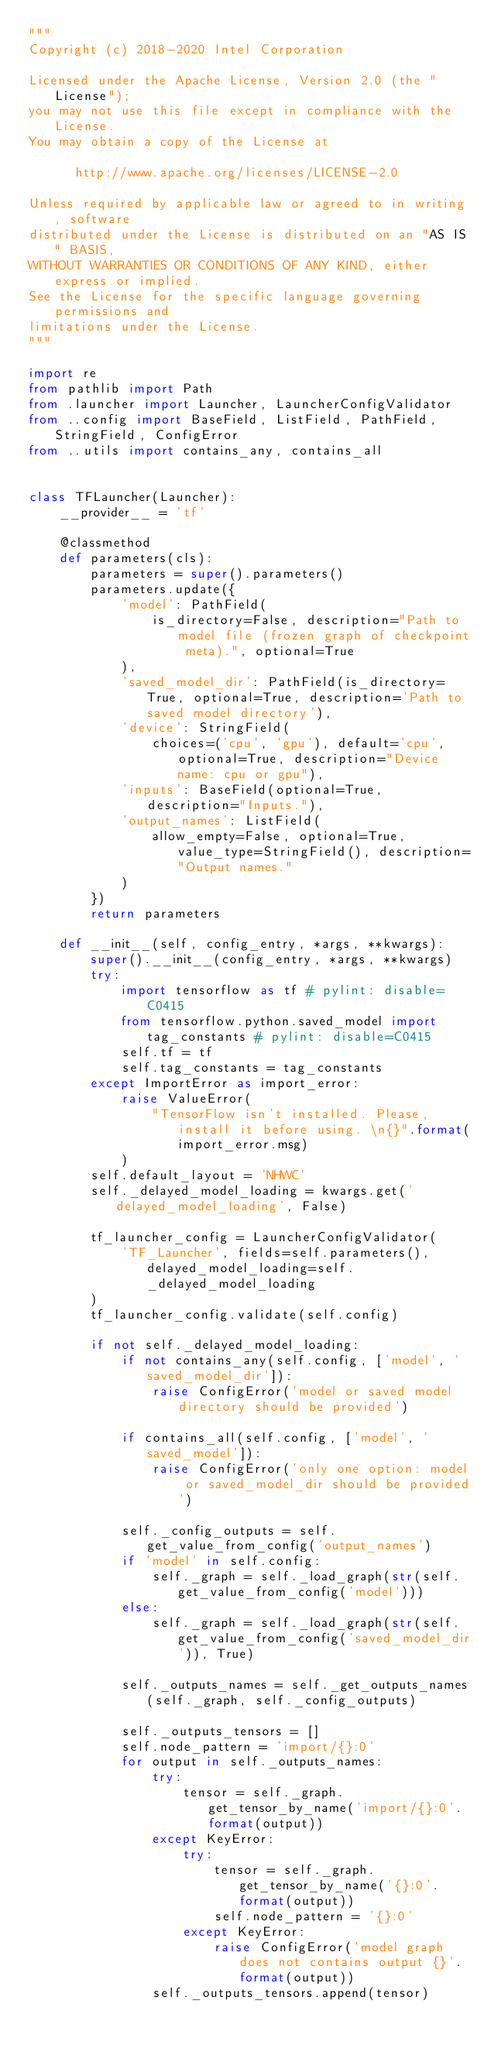<code> <loc_0><loc_0><loc_500><loc_500><_Python_>"""
Copyright (c) 2018-2020 Intel Corporation

Licensed under the Apache License, Version 2.0 (the "License");
you may not use this file except in compliance with the License.
You may obtain a copy of the License at

      http://www.apache.org/licenses/LICENSE-2.0

Unless required by applicable law or agreed to in writing, software
distributed under the License is distributed on an "AS IS" BASIS,
WITHOUT WARRANTIES OR CONDITIONS OF ANY KIND, either express or implied.
See the License for the specific language governing permissions and
limitations under the License.
"""

import re
from pathlib import Path
from .launcher import Launcher, LauncherConfigValidator
from ..config import BaseField, ListField, PathField, StringField, ConfigError
from ..utils import contains_any, contains_all


class TFLauncher(Launcher):
    __provider__ = 'tf'

    @classmethod
    def parameters(cls):
        parameters = super().parameters()
        parameters.update({
            'model': PathField(
                is_directory=False, description="Path to model file (frozen graph of checkpoint meta).", optional=True
            ),
            'saved_model_dir': PathField(is_directory=True, optional=True, description='Path to saved model directory'),
            'device': StringField(
                choices=('cpu', 'gpu'), default='cpu', optional=True, description="Device name: cpu or gpu"),
            'inputs': BaseField(optional=True, description="Inputs."),
            'output_names': ListField(
                allow_empty=False, optional=True, value_type=StringField(), description="Output names."
            )
        })
        return parameters

    def __init__(self, config_entry, *args, **kwargs):
        super().__init__(config_entry, *args, **kwargs)
        try:
            import tensorflow as tf # pylint: disable=C0415
            from tensorflow.python.saved_model import tag_constants # pylint: disable=C0415
            self.tf = tf
            self.tag_constants = tag_constants
        except ImportError as import_error:
            raise ValueError(
                "TensorFlow isn't installed. Please, install it before using. \n{}".format(import_error.msg)
            )
        self.default_layout = 'NHWC'
        self._delayed_model_loading = kwargs.get('delayed_model_loading', False)

        tf_launcher_config = LauncherConfigValidator(
            'TF_Launcher', fields=self.parameters(), delayed_model_loading=self._delayed_model_loading
        )
        tf_launcher_config.validate(self.config)

        if not self._delayed_model_loading:
            if not contains_any(self.config, ['model', 'saved_model_dir']):
                raise ConfigError('model or saved model directory should be provided')

            if contains_all(self.config, ['model', 'saved_model']):
                raise ConfigError('only one option: model or saved_model_dir should be provided')

            self._config_outputs = self.get_value_from_config('output_names')
            if 'model' in self.config:
                self._graph = self._load_graph(str(self.get_value_from_config('model')))
            else:
                self._graph = self._load_graph(str(self.get_value_from_config('saved_model_dir')), True)

            self._outputs_names = self._get_outputs_names(self._graph, self._config_outputs)

            self._outputs_tensors = []
            self.node_pattern = 'import/{}:0'
            for output in self._outputs_names:
                try:
                    tensor = self._graph.get_tensor_by_name('import/{}:0'.format(output))
                except KeyError:
                    try:
                        tensor = self._graph.get_tensor_by_name('{}:0'.format(output))
                        self.node_pattern = '{}:0'
                    except KeyError:
                        raise ConfigError('model graph does not contains output {}'.format(output))
                self._outputs_tensors.append(tensor)
</code> 